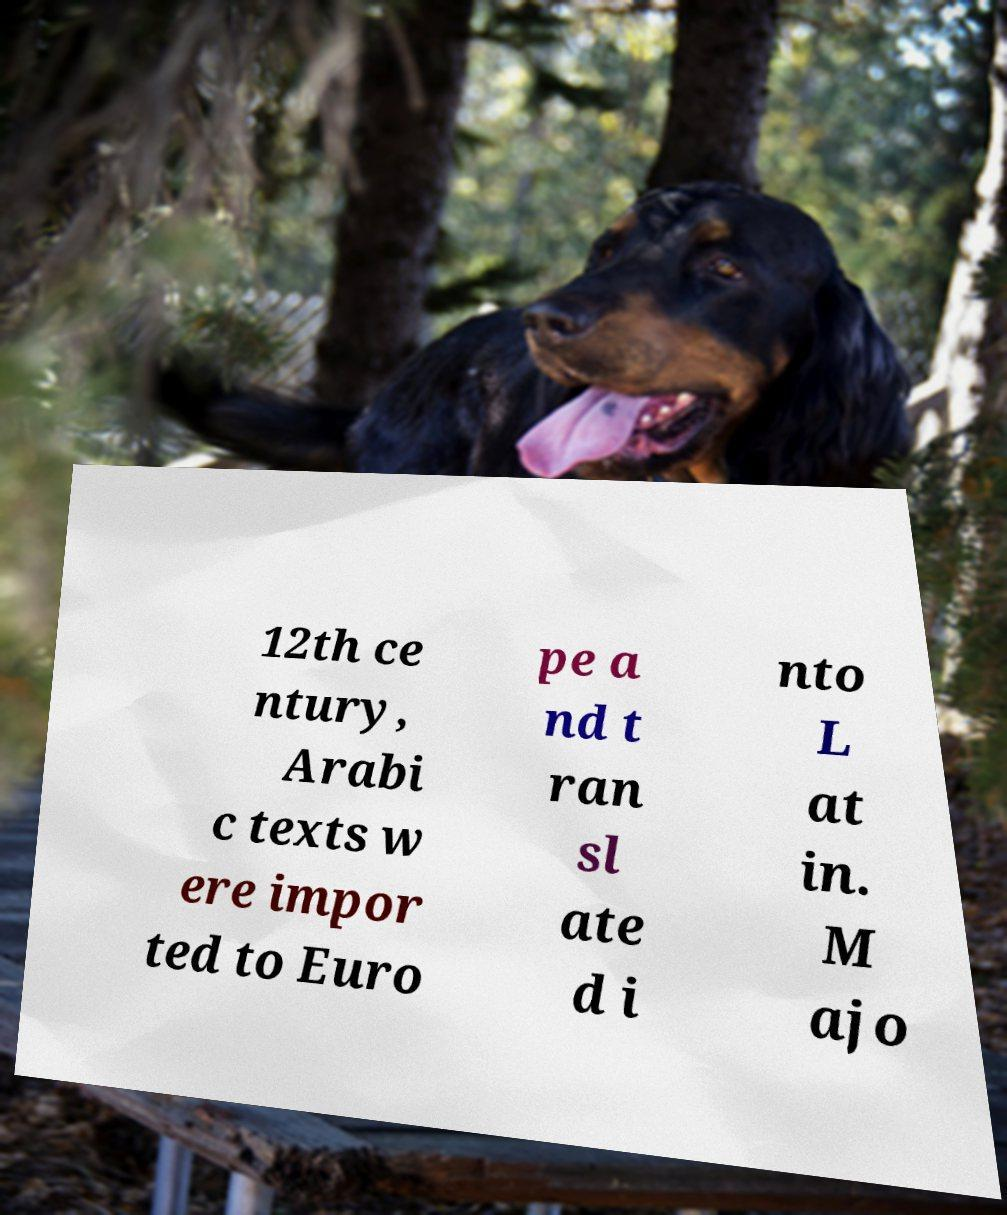Please identify and transcribe the text found in this image. 12th ce ntury, Arabi c texts w ere impor ted to Euro pe a nd t ran sl ate d i nto L at in. M ajo 